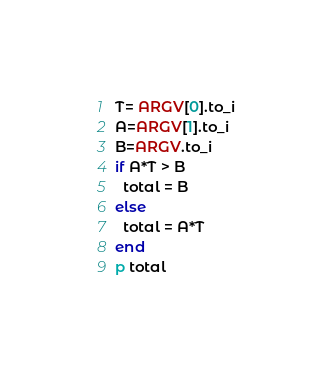Convert code to text. <code><loc_0><loc_0><loc_500><loc_500><_Ruby_>T= ARGV[0].to_i
A=ARGV[1].to_i
B=ARGV.to_i
if A*T > B
  total = B
else
  total = A*T
end
p total
</code> 